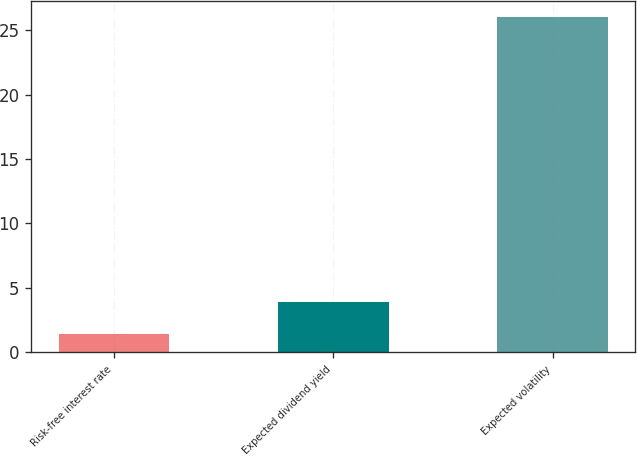Convert chart. <chart><loc_0><loc_0><loc_500><loc_500><bar_chart><fcel>Risk-free interest rate<fcel>Expected dividend yield<fcel>Expected volatility<nl><fcel>1.42<fcel>3.88<fcel>26<nl></chart> 